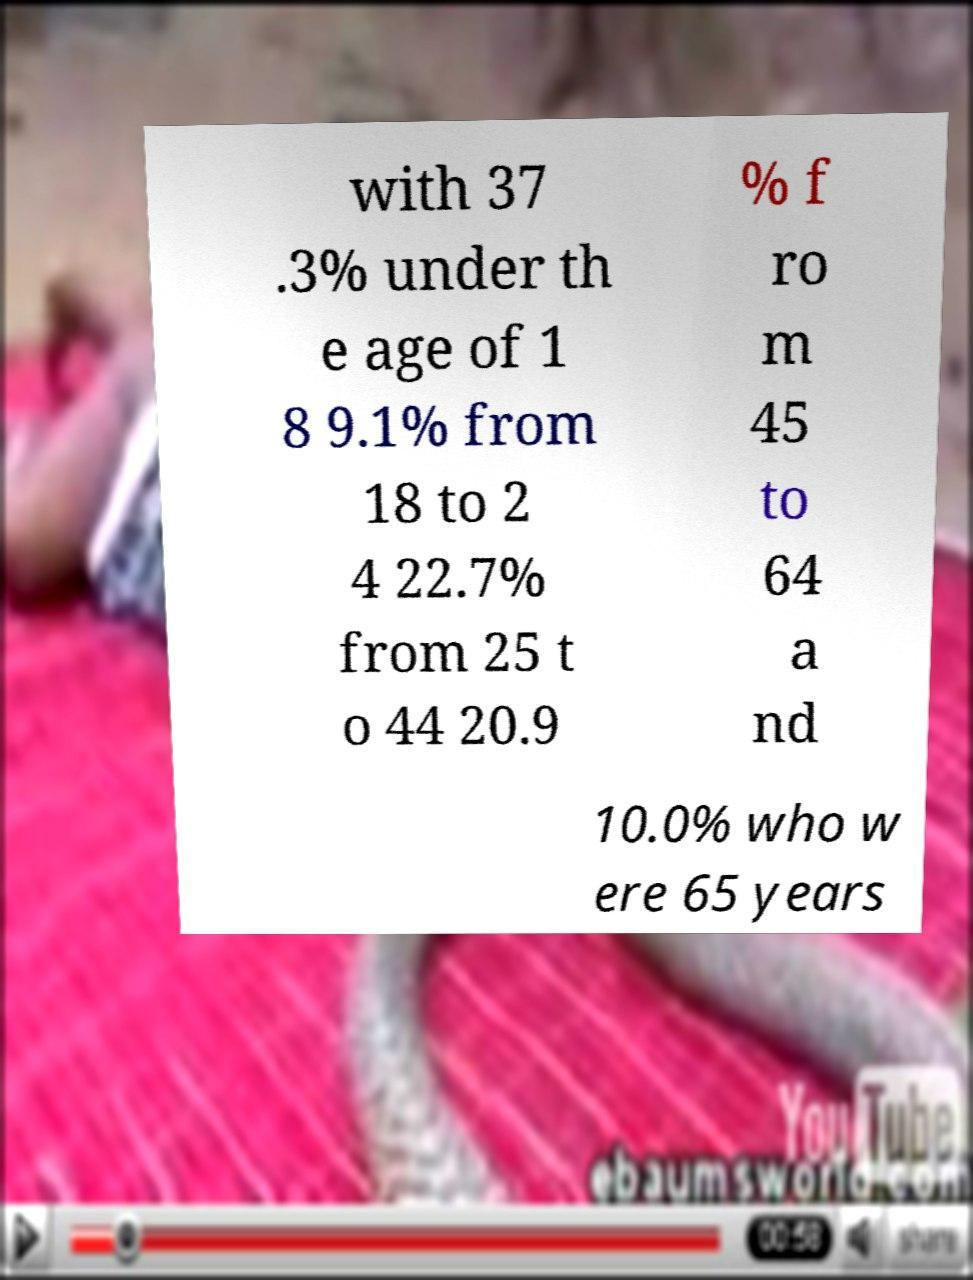I need the written content from this picture converted into text. Can you do that? with 37 .3% under th e age of 1 8 9.1% from 18 to 2 4 22.7% from 25 t o 44 20.9 % f ro m 45 to 64 a nd 10.0% who w ere 65 years 